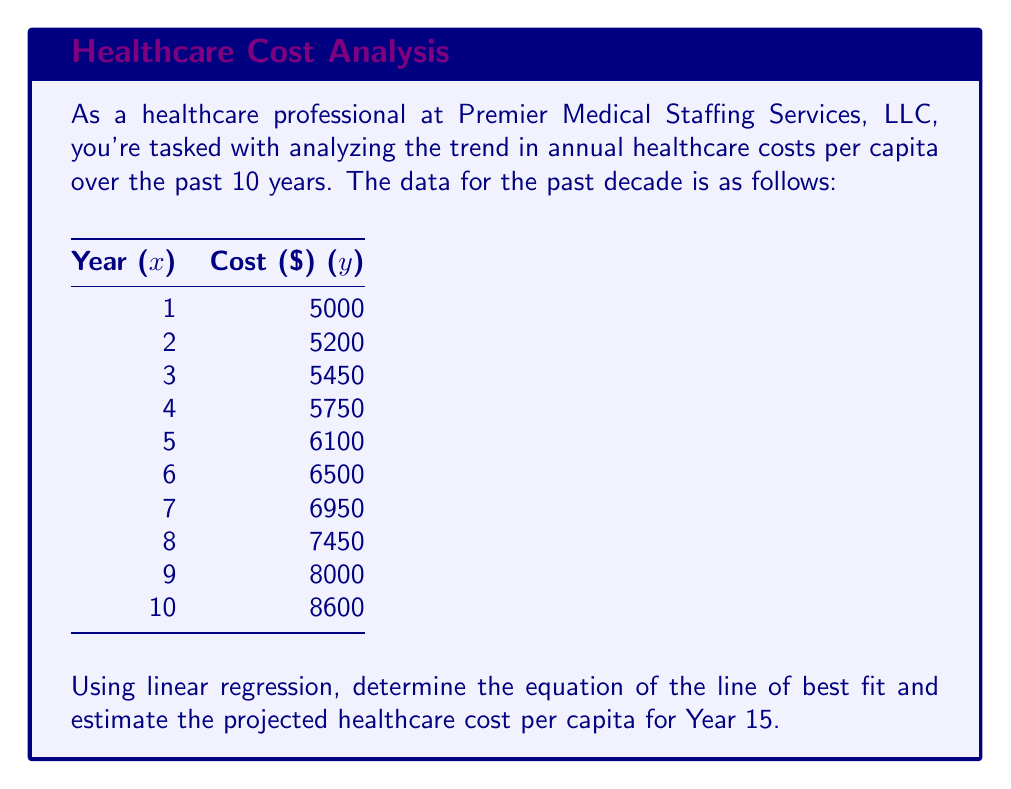What is the answer to this math problem? To solve this problem, we'll use linear regression to find the line of best fit and then use that equation to project the cost for Year 15. Let's follow these steps:

1) First, we need to calculate the following sums:
   $$\sum x = 55$$
   $$\sum y = 65000$$
   $$\sum xy = 392500$$
   $$\sum x^2 = 385$$
   $$n = 10$$ (number of data points)

2) Now, we can use these sums to calculate the slope (m) and y-intercept (b) of the line of best fit:

   $$m = \frac{n\sum xy - \sum x \sum y}{n\sum x^2 - (\sum x)^2}$$
   
   $$m = \frac{10(392500) - 55(65000)}{10(385) - 55^2} = \frac{3925000 - 3575000}{3850 - 3025} = \frac{350000}{825} = 424.24$$

   $$b = \frac{\sum y - m\sum x}{n}$$
   
   $$b = \frac{65000 - 424.24(55)}{10} = \frac{65000 - 23333.2}{10} = 4166.68$$

3) The equation of the line of best fit is:
   $$y = 424.24x + 4166.68$$

4) To estimate the cost for Year 15, we substitute x = 15 into our equation:
   $$y = 424.24(15) + 4166.68 = 6363.6 + 4166.68 = 10530.28$$

Therefore, the projected healthcare cost per capita for Year 15 is approximately $10,530.28.
Answer: $10,530.28 